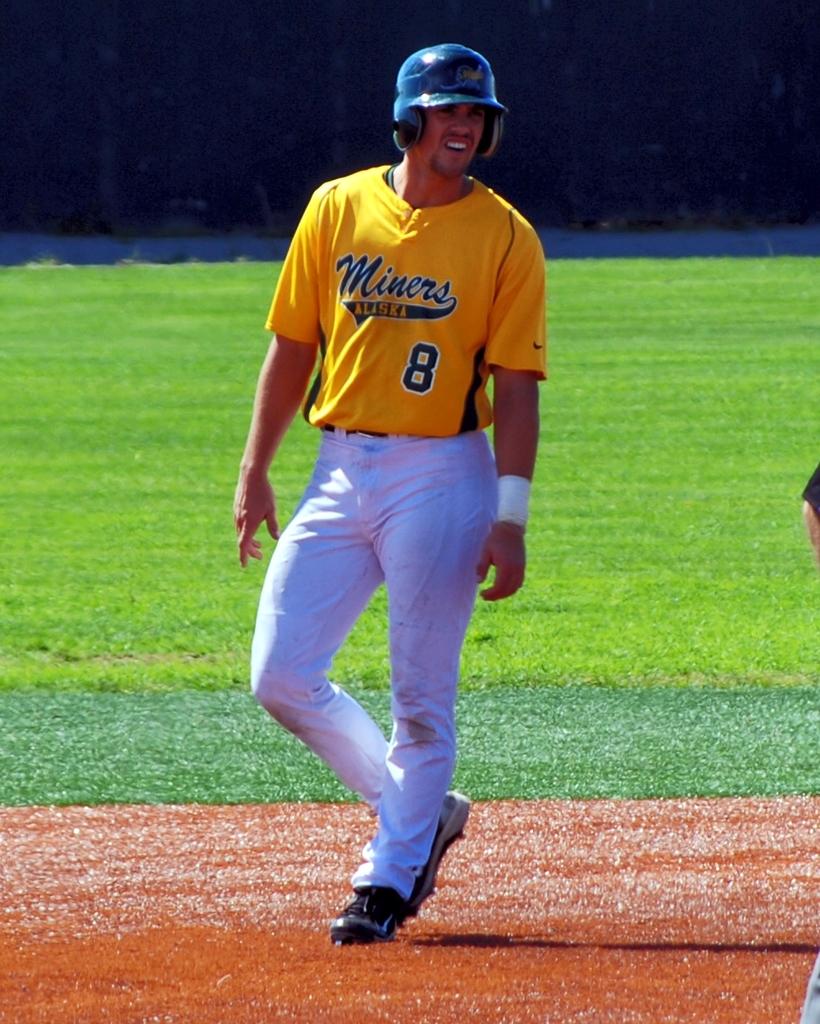What number is the players jersey?
Offer a terse response. 8. 